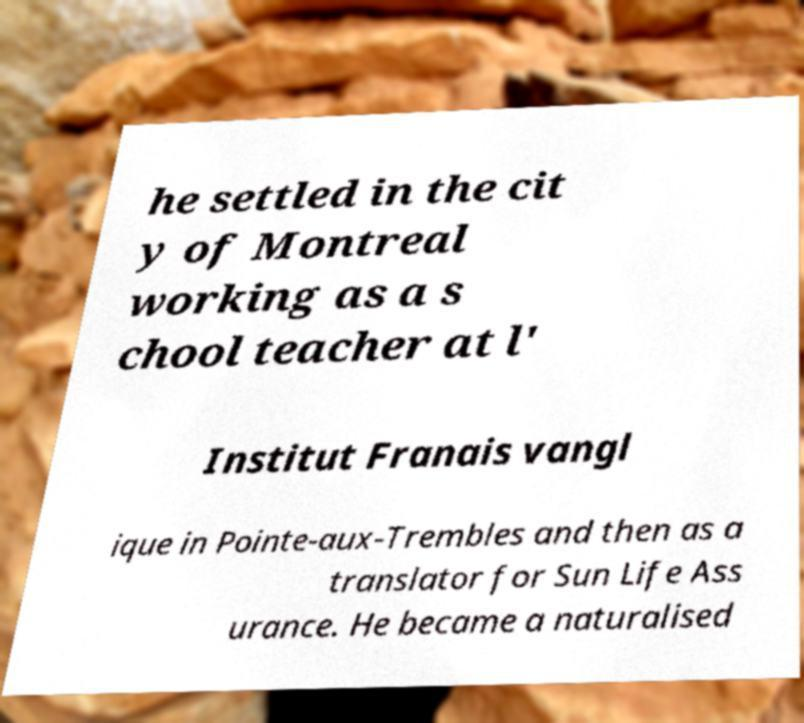Please read and relay the text visible in this image. What does it say? he settled in the cit y of Montreal working as a s chool teacher at l' Institut Franais vangl ique in Pointe-aux-Trembles and then as a translator for Sun Life Ass urance. He became a naturalised 